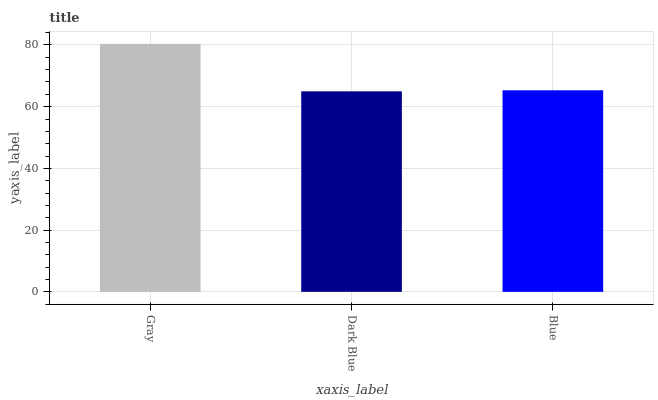Is Dark Blue the minimum?
Answer yes or no. Yes. Is Gray the maximum?
Answer yes or no. Yes. Is Blue the minimum?
Answer yes or no. No. Is Blue the maximum?
Answer yes or no. No. Is Blue greater than Dark Blue?
Answer yes or no. Yes. Is Dark Blue less than Blue?
Answer yes or no. Yes. Is Dark Blue greater than Blue?
Answer yes or no. No. Is Blue less than Dark Blue?
Answer yes or no. No. Is Blue the high median?
Answer yes or no. Yes. Is Blue the low median?
Answer yes or no. Yes. Is Dark Blue the high median?
Answer yes or no. No. Is Gray the low median?
Answer yes or no. No. 